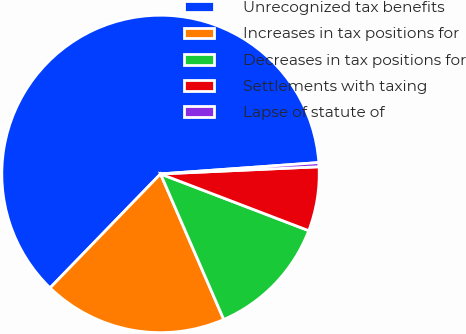Convert chart to OTSL. <chart><loc_0><loc_0><loc_500><loc_500><pie_chart><fcel>Unrecognized tax benefits<fcel>Increases in tax positions for<fcel>Decreases in tax positions for<fcel>Settlements with taxing<fcel>Lapse of statute of<nl><fcel>61.62%<fcel>18.78%<fcel>12.66%<fcel>6.54%<fcel>0.42%<nl></chart> 